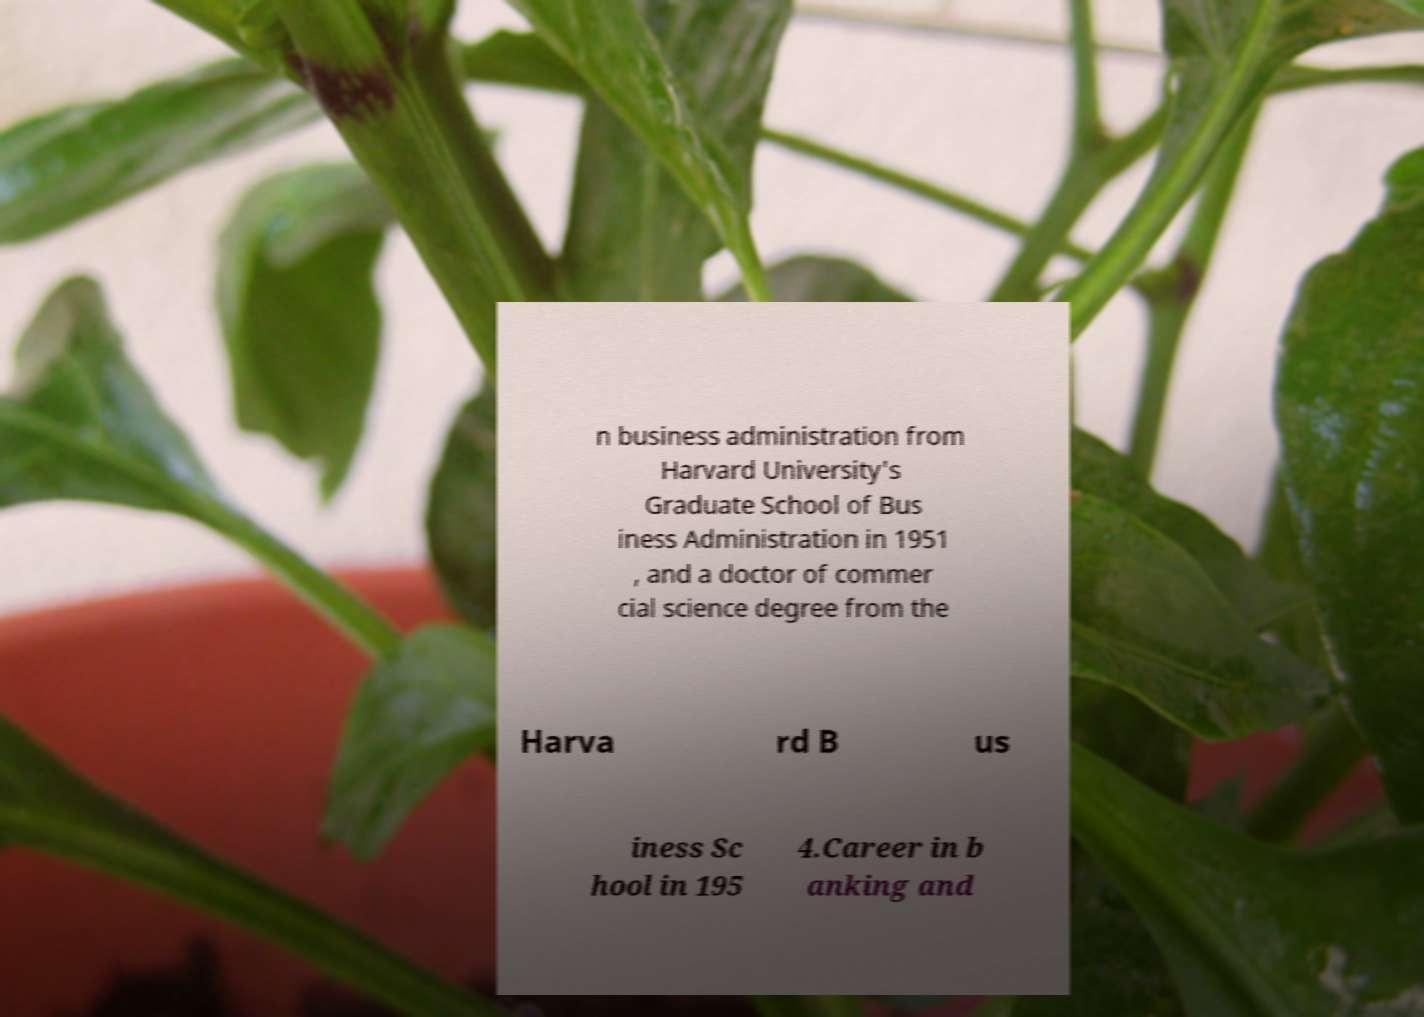For documentation purposes, I need the text within this image transcribed. Could you provide that? n business administration from Harvard University's Graduate School of Bus iness Administration in 1951 , and a doctor of commer cial science degree from the Harva rd B us iness Sc hool in 195 4.Career in b anking and 